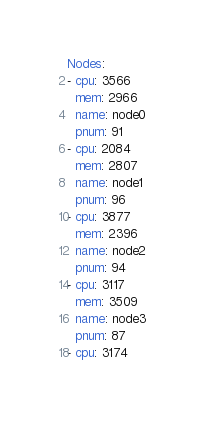<code> <loc_0><loc_0><loc_500><loc_500><_YAML_>Nodes:
- cpu: 3566
  mem: 2966
  name: node0
  pnum: 91
- cpu: 2084
  mem: 2807
  name: node1
  pnum: 96
- cpu: 3877
  mem: 2396
  name: node2
  pnum: 94
- cpu: 3117
  mem: 3509
  name: node3
  pnum: 87
- cpu: 3174</code> 